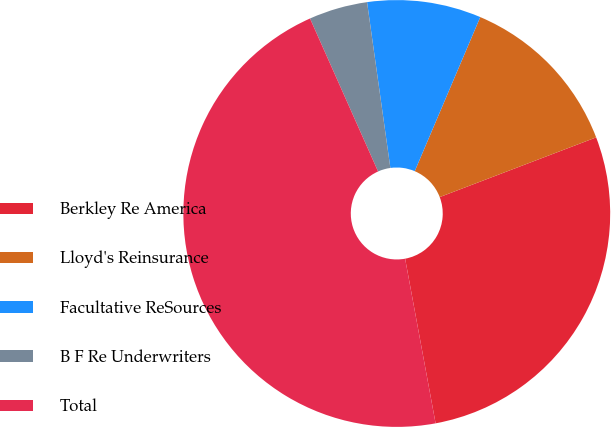Convert chart to OTSL. <chart><loc_0><loc_0><loc_500><loc_500><pie_chart><fcel>Berkley Re America<fcel>Lloyd's Reinsurance<fcel>Facultative ReSources<fcel>B F Re Underwriters<fcel>Total<nl><fcel>27.89%<fcel>12.8%<fcel>8.62%<fcel>4.44%<fcel>46.25%<nl></chart> 